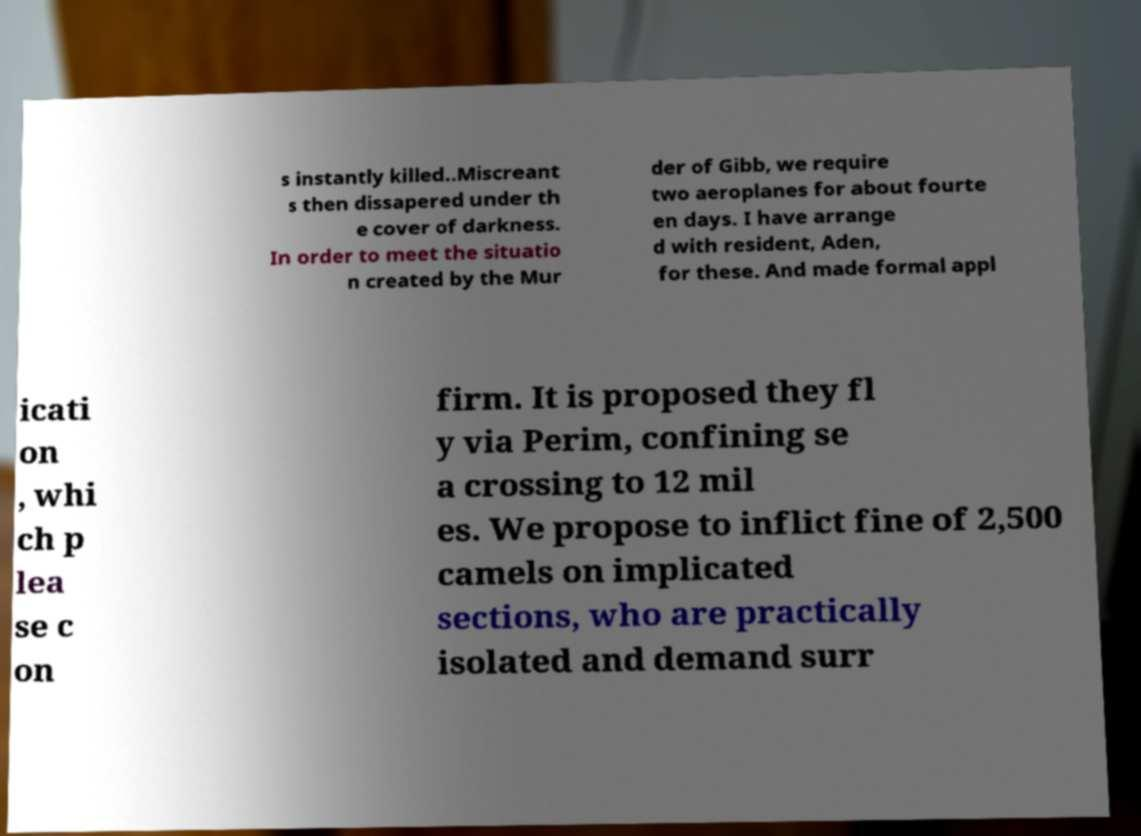Please read and relay the text visible in this image. What does it say? s instantly killed..Miscreant s then dissapered under th e cover of darkness. In order to meet the situatio n created by the Mur der of Gibb, we require two aeroplanes for about fourte en days. I have arrange d with resident, Aden, for these. And made formal appl icati on , whi ch p lea se c on firm. It is proposed they fl y via Perim, confining se a crossing to 12 mil es. We propose to inflict fine of 2,500 camels on implicated sections, who are practically isolated and demand surr 